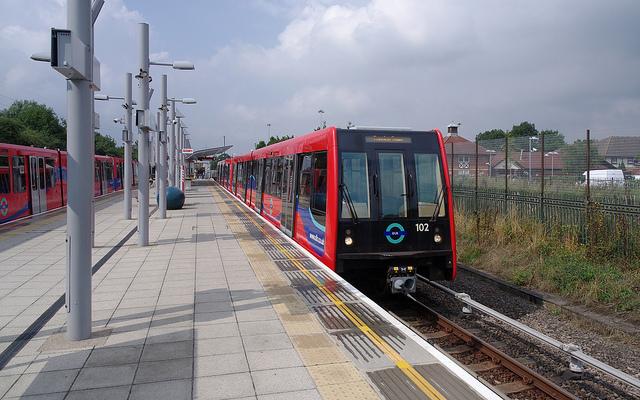Are their passengers waiting for the train?
Write a very short answer. No. Is this train moving fast?
Give a very brief answer. No. Who is on the platform?
Write a very short answer. No one. How many people are waiting on the platform?
Answer briefly. 0. 